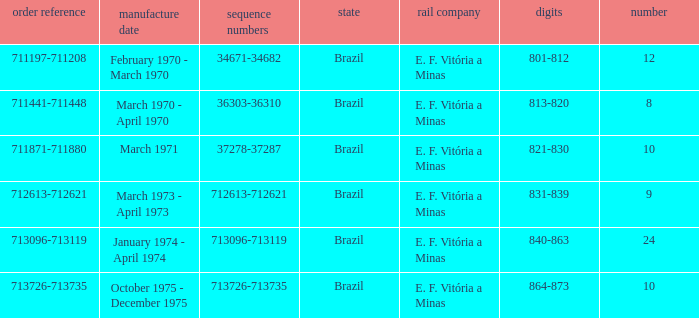The order number 713726-713735 has what serial number? 713726-713735. 